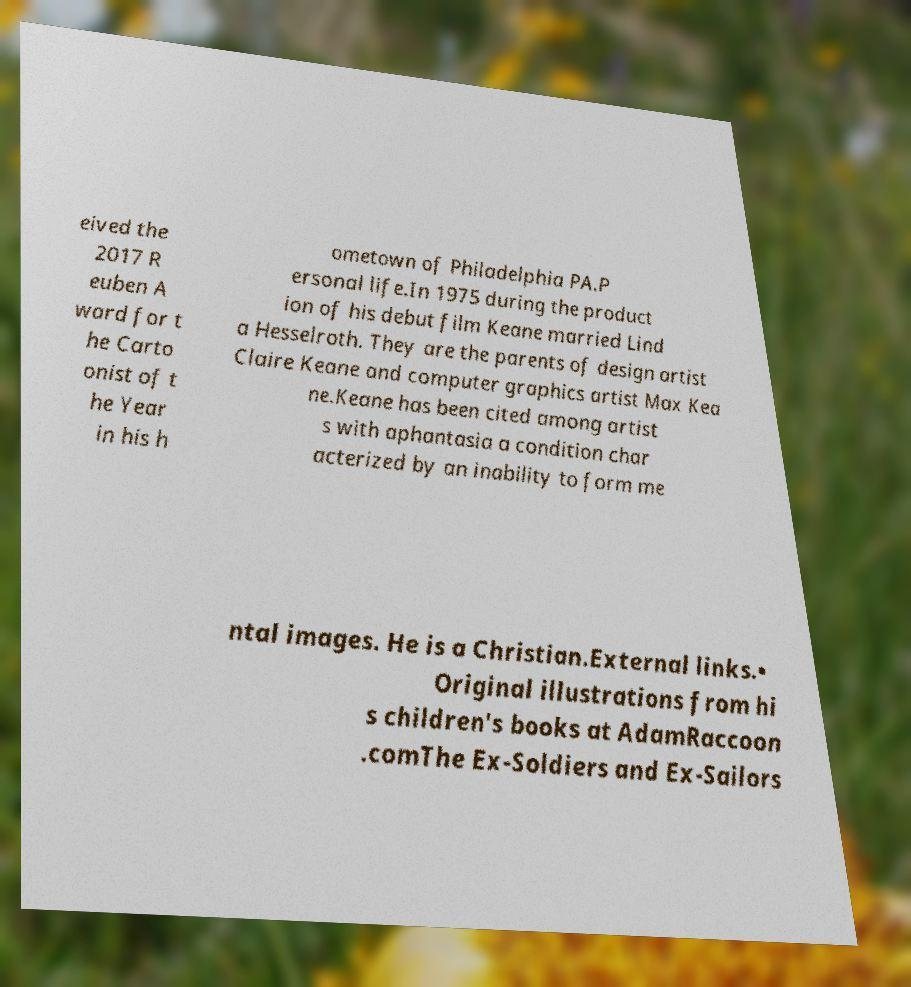There's text embedded in this image that I need extracted. Can you transcribe it verbatim? eived the 2017 R euben A ward for t he Carto onist of t he Year in his h ometown of Philadelphia PA.P ersonal life.In 1975 during the product ion of his debut film Keane married Lind a Hesselroth. They are the parents of design artist Claire Keane and computer graphics artist Max Kea ne.Keane has been cited among artist s with aphantasia a condition char acterized by an inability to form me ntal images. He is a Christian.External links.• Original illustrations from hi s children's books at AdamRaccoon .comThe Ex-Soldiers and Ex-Sailors 